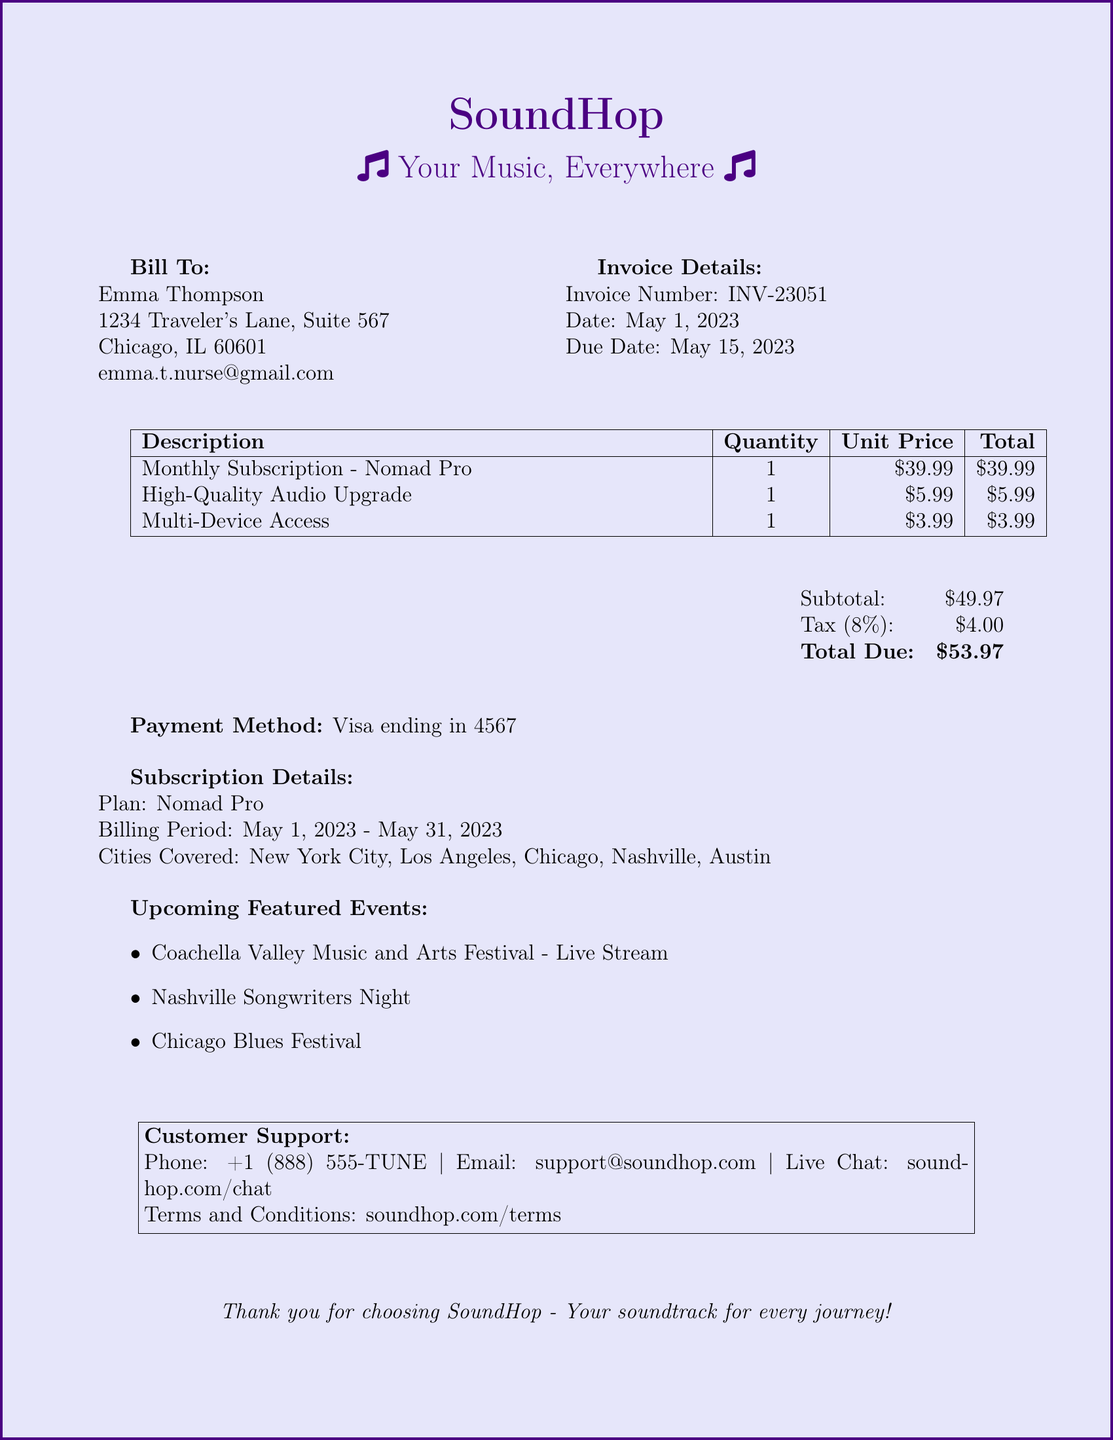What is the invoice number? The invoice number is listed under Invoice Details in the document.
Answer: INV-23051 What is the due date for the invoice? The due date is provided in the Invoice Details section.
Answer: May 15, 2023 How much is the Monthly Subscription - Nomad Pro? The price for the Monthly Subscription can be found in the table of Descriptions.
Answer: $39.99 What payment method was used? The payment method is specified at the bottom of the invoice.
Answer: Visa ending in 4567 What is the total due amount? The total due amount is calculated from the subtotal and tax at the end of the document.
Answer: $53.97 Which cities are covered by the subscription? The cities covered are listed under Subscription Details in the document.
Answer: New York City, Los Angeles, Chicago, Nashville, Austin How much is the tax applied? The tax amount is noted in the final breakdown section of the invoice.
Answer: $4.00 What is the billing period for the plan? The billing period is mentioned in the Subscription Details section.
Answer: May 1, 2023 - May 31, 2023 What are some upcoming featured events? The featured events are listed under Upcoming Featured Events in the document.
Answer: Coachella Valley Music and Arts Festival - Live Stream, Nashville Songwriters Night, Chicago Blues Festival 